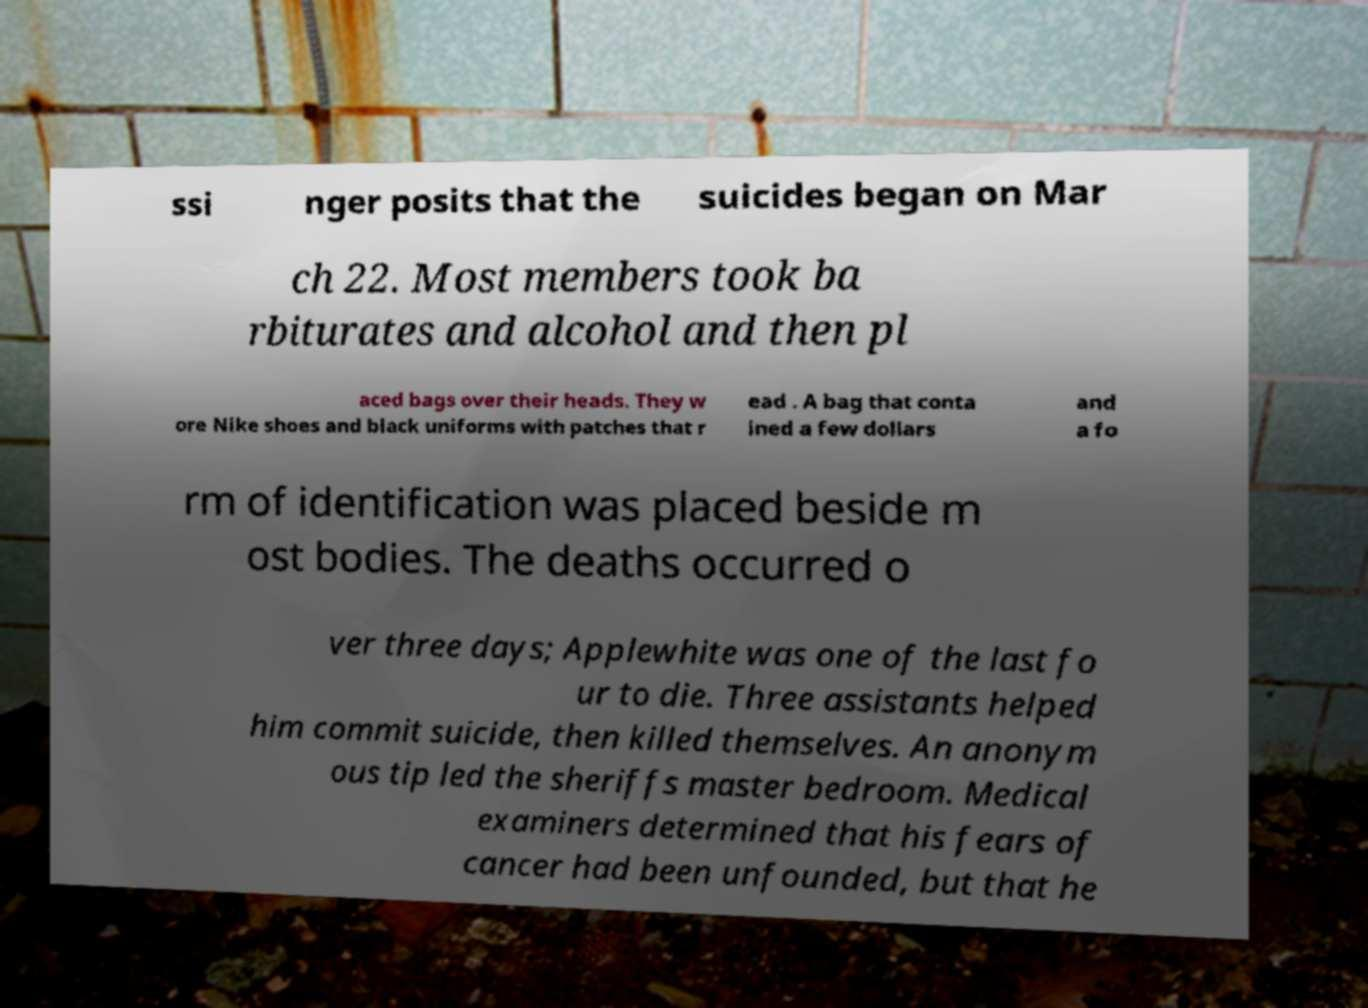There's text embedded in this image that I need extracted. Can you transcribe it verbatim? ssi nger posits that the suicides began on Mar ch 22. Most members took ba rbiturates and alcohol and then pl aced bags over their heads. They w ore Nike shoes and black uniforms with patches that r ead . A bag that conta ined a few dollars and a fo rm of identification was placed beside m ost bodies. The deaths occurred o ver three days; Applewhite was one of the last fo ur to die. Three assistants helped him commit suicide, then killed themselves. An anonym ous tip led the sheriffs master bedroom. Medical examiners determined that his fears of cancer had been unfounded, but that he 